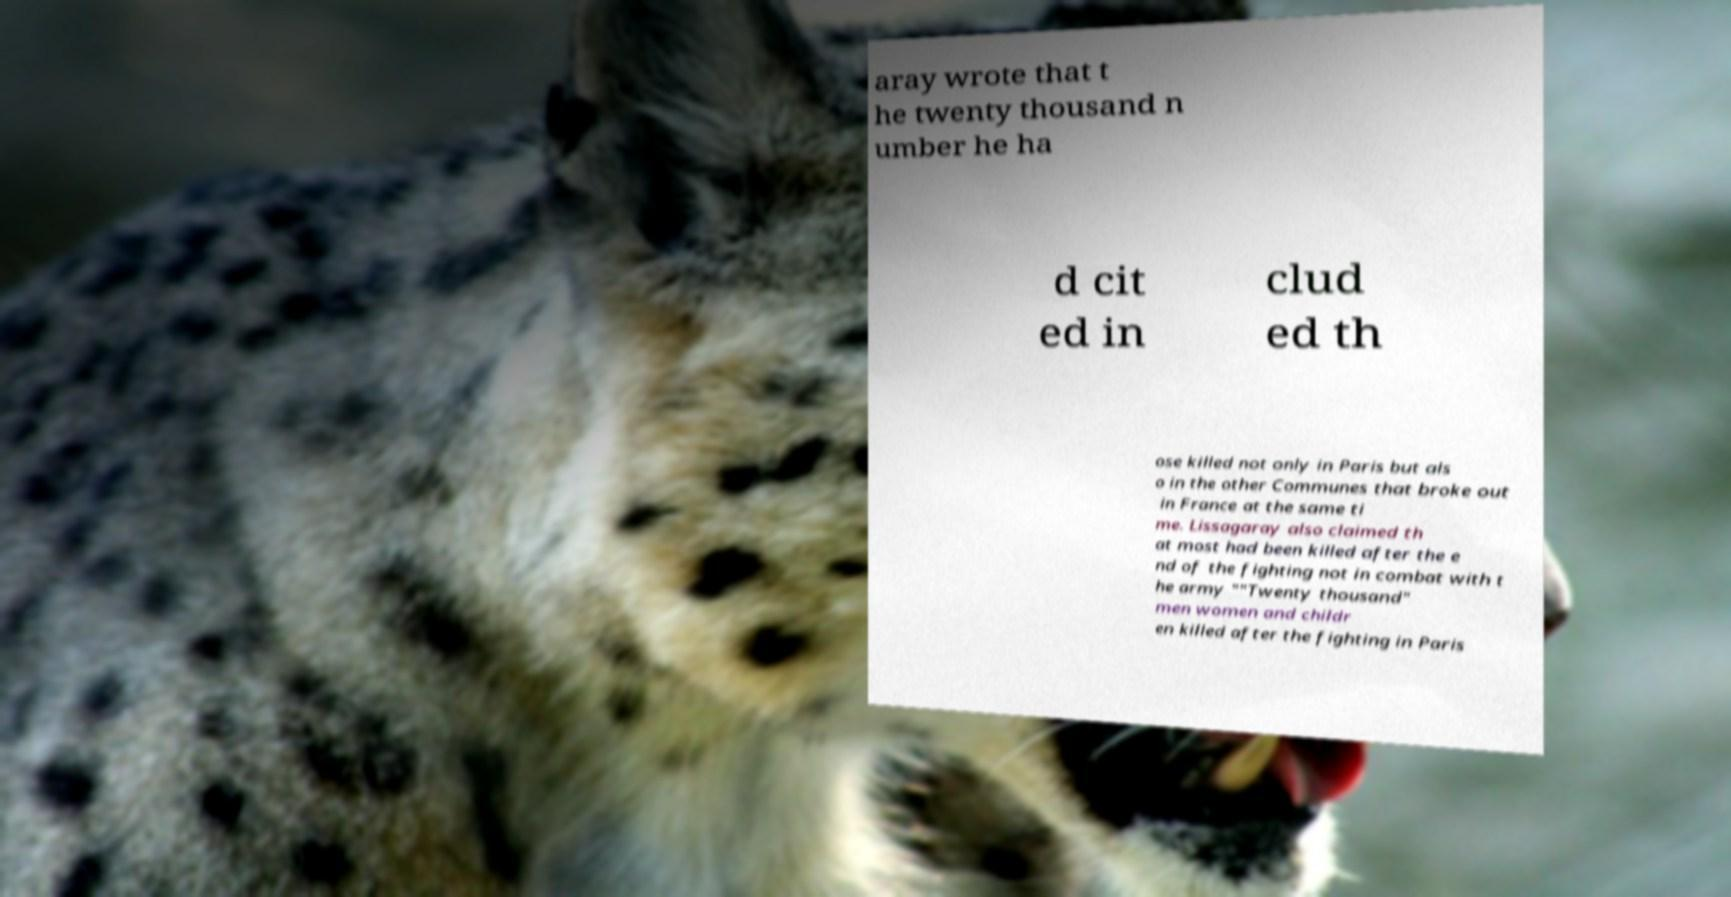I need the written content from this picture converted into text. Can you do that? aray wrote that t he twenty thousand n umber he ha d cit ed in clud ed th ose killed not only in Paris but als o in the other Communes that broke out in France at the same ti me. Lissagaray also claimed th at most had been killed after the e nd of the fighting not in combat with t he army ""Twenty thousand" men women and childr en killed after the fighting in Paris 